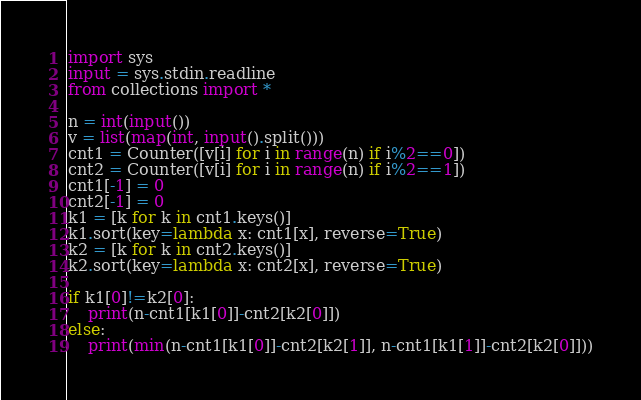<code> <loc_0><loc_0><loc_500><loc_500><_Python_>import sys
input = sys.stdin.readline
from collections import *

n = int(input())
v = list(map(int, input().split()))
cnt1 = Counter([v[i] for i in range(n) if i%2==0])
cnt2 = Counter([v[i] for i in range(n) if i%2==1])
cnt1[-1] = 0
cnt2[-1] = 0
k1 = [k for k in cnt1.keys()]
k1.sort(key=lambda x: cnt1[x], reverse=True)
k2 = [k for k in cnt2.keys()]
k2.sort(key=lambda x: cnt2[x], reverse=True)

if k1[0]!=k2[0]:
    print(n-cnt1[k1[0]]-cnt2[k2[0]])
else:
    print(min(n-cnt1[k1[0]]-cnt2[k2[1]], n-cnt1[k1[1]]-cnt2[k2[0]]))</code> 